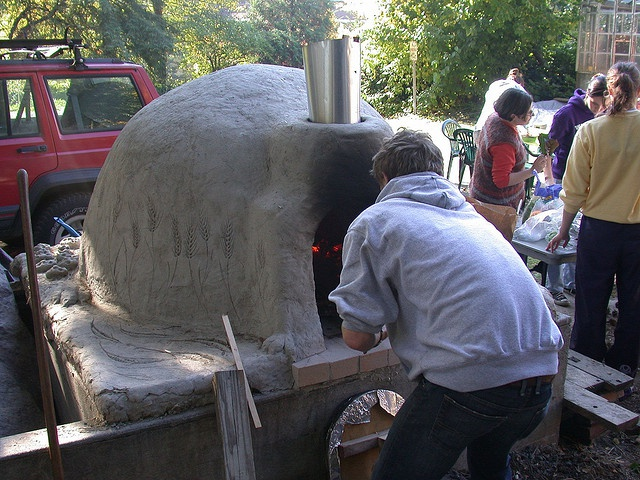Describe the objects in this image and their specific colors. I can see oven in gray, black, and darkgray tones, people in gray, black, and darkgray tones, car in gray, black, maroon, and purple tones, people in gray and black tones, and people in gray, black, and maroon tones in this image. 